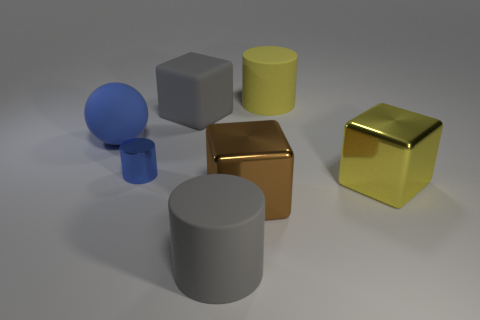Add 1 metal objects. How many objects exist? 8 Subtract all cylinders. How many objects are left? 4 Add 7 gray cylinders. How many gray cylinders exist? 8 Subtract 0 blue blocks. How many objects are left? 7 Subtract all large rubber spheres. Subtract all blocks. How many objects are left? 3 Add 6 large blue spheres. How many large blue spheres are left? 7 